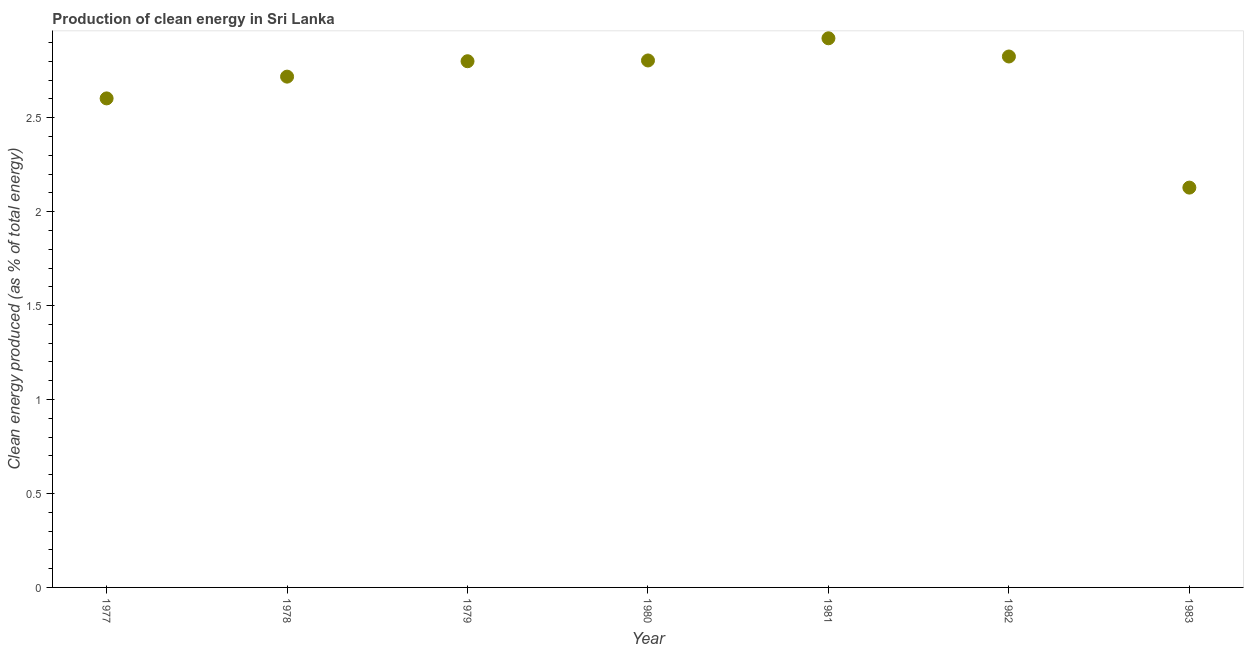What is the production of clean energy in 1980?
Your answer should be compact. 2.81. Across all years, what is the maximum production of clean energy?
Keep it short and to the point. 2.92. Across all years, what is the minimum production of clean energy?
Offer a terse response. 2.13. In which year was the production of clean energy maximum?
Provide a succinct answer. 1981. What is the sum of the production of clean energy?
Keep it short and to the point. 18.81. What is the difference between the production of clean energy in 1978 and 1979?
Provide a short and direct response. -0.08. What is the average production of clean energy per year?
Provide a succinct answer. 2.69. What is the median production of clean energy?
Your answer should be compact. 2.8. In how many years, is the production of clean energy greater than 0.2 %?
Make the answer very short. 7. Do a majority of the years between 1982 and 1980 (inclusive) have production of clean energy greater than 1.1 %?
Ensure brevity in your answer.  No. What is the ratio of the production of clean energy in 1982 to that in 1983?
Offer a very short reply. 1.33. Is the production of clean energy in 1981 less than that in 1983?
Offer a very short reply. No. What is the difference between the highest and the second highest production of clean energy?
Ensure brevity in your answer.  0.1. What is the difference between the highest and the lowest production of clean energy?
Offer a terse response. 0.79. How many dotlines are there?
Offer a terse response. 1. How many years are there in the graph?
Ensure brevity in your answer.  7. Are the values on the major ticks of Y-axis written in scientific E-notation?
Provide a succinct answer. No. Does the graph contain grids?
Your response must be concise. No. What is the title of the graph?
Your answer should be compact. Production of clean energy in Sri Lanka. What is the label or title of the Y-axis?
Offer a very short reply. Clean energy produced (as % of total energy). What is the Clean energy produced (as % of total energy) in 1977?
Make the answer very short. 2.6. What is the Clean energy produced (as % of total energy) in 1978?
Your response must be concise. 2.72. What is the Clean energy produced (as % of total energy) in 1979?
Offer a terse response. 2.8. What is the Clean energy produced (as % of total energy) in 1980?
Ensure brevity in your answer.  2.81. What is the Clean energy produced (as % of total energy) in 1981?
Give a very brief answer. 2.92. What is the Clean energy produced (as % of total energy) in 1982?
Offer a very short reply. 2.83. What is the Clean energy produced (as % of total energy) in 1983?
Your answer should be compact. 2.13. What is the difference between the Clean energy produced (as % of total energy) in 1977 and 1978?
Offer a very short reply. -0.12. What is the difference between the Clean energy produced (as % of total energy) in 1977 and 1979?
Provide a succinct answer. -0.2. What is the difference between the Clean energy produced (as % of total energy) in 1977 and 1980?
Give a very brief answer. -0.2. What is the difference between the Clean energy produced (as % of total energy) in 1977 and 1981?
Your answer should be very brief. -0.32. What is the difference between the Clean energy produced (as % of total energy) in 1977 and 1982?
Your answer should be compact. -0.22. What is the difference between the Clean energy produced (as % of total energy) in 1977 and 1983?
Provide a short and direct response. 0.47. What is the difference between the Clean energy produced (as % of total energy) in 1978 and 1979?
Your answer should be very brief. -0.08. What is the difference between the Clean energy produced (as % of total energy) in 1978 and 1980?
Keep it short and to the point. -0.09. What is the difference between the Clean energy produced (as % of total energy) in 1978 and 1981?
Offer a very short reply. -0.2. What is the difference between the Clean energy produced (as % of total energy) in 1978 and 1982?
Keep it short and to the point. -0.11. What is the difference between the Clean energy produced (as % of total energy) in 1978 and 1983?
Ensure brevity in your answer.  0.59. What is the difference between the Clean energy produced (as % of total energy) in 1979 and 1980?
Make the answer very short. -0. What is the difference between the Clean energy produced (as % of total energy) in 1979 and 1981?
Keep it short and to the point. -0.12. What is the difference between the Clean energy produced (as % of total energy) in 1979 and 1982?
Provide a succinct answer. -0.03. What is the difference between the Clean energy produced (as % of total energy) in 1979 and 1983?
Offer a very short reply. 0.67. What is the difference between the Clean energy produced (as % of total energy) in 1980 and 1981?
Your answer should be compact. -0.12. What is the difference between the Clean energy produced (as % of total energy) in 1980 and 1982?
Keep it short and to the point. -0.02. What is the difference between the Clean energy produced (as % of total energy) in 1980 and 1983?
Offer a very short reply. 0.68. What is the difference between the Clean energy produced (as % of total energy) in 1981 and 1982?
Your answer should be very brief. 0.1. What is the difference between the Clean energy produced (as % of total energy) in 1981 and 1983?
Keep it short and to the point. 0.79. What is the difference between the Clean energy produced (as % of total energy) in 1982 and 1983?
Ensure brevity in your answer.  0.7. What is the ratio of the Clean energy produced (as % of total energy) in 1977 to that in 1978?
Your answer should be compact. 0.96. What is the ratio of the Clean energy produced (as % of total energy) in 1977 to that in 1979?
Offer a very short reply. 0.93. What is the ratio of the Clean energy produced (as % of total energy) in 1977 to that in 1980?
Keep it short and to the point. 0.93. What is the ratio of the Clean energy produced (as % of total energy) in 1977 to that in 1981?
Your answer should be compact. 0.89. What is the ratio of the Clean energy produced (as % of total energy) in 1977 to that in 1982?
Your answer should be very brief. 0.92. What is the ratio of the Clean energy produced (as % of total energy) in 1977 to that in 1983?
Your response must be concise. 1.22. What is the ratio of the Clean energy produced (as % of total energy) in 1978 to that in 1982?
Your answer should be very brief. 0.96. What is the ratio of the Clean energy produced (as % of total energy) in 1978 to that in 1983?
Give a very brief answer. 1.28. What is the ratio of the Clean energy produced (as % of total energy) in 1979 to that in 1980?
Provide a succinct answer. 1. What is the ratio of the Clean energy produced (as % of total energy) in 1979 to that in 1981?
Provide a succinct answer. 0.96. What is the ratio of the Clean energy produced (as % of total energy) in 1979 to that in 1982?
Provide a short and direct response. 0.99. What is the ratio of the Clean energy produced (as % of total energy) in 1979 to that in 1983?
Ensure brevity in your answer.  1.32. What is the ratio of the Clean energy produced (as % of total energy) in 1980 to that in 1981?
Keep it short and to the point. 0.96. What is the ratio of the Clean energy produced (as % of total energy) in 1980 to that in 1983?
Keep it short and to the point. 1.32. What is the ratio of the Clean energy produced (as % of total energy) in 1981 to that in 1982?
Make the answer very short. 1.03. What is the ratio of the Clean energy produced (as % of total energy) in 1981 to that in 1983?
Keep it short and to the point. 1.37. What is the ratio of the Clean energy produced (as % of total energy) in 1982 to that in 1983?
Offer a very short reply. 1.33. 